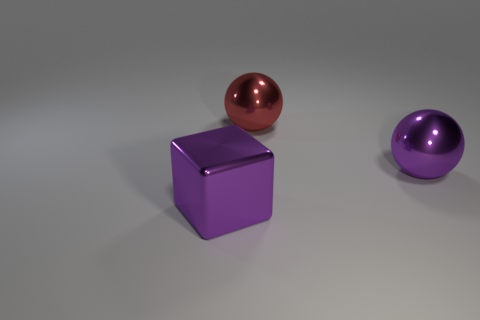The large thing that is the same color as the large cube is what shape?
Your response must be concise. Sphere. Are there any green cylinders?
Provide a succinct answer. No. What size is the red ball that is made of the same material as the purple sphere?
Offer a very short reply. Large. The purple metallic thing behind the object in front of the large ball that is on the right side of the large red metal sphere is what shape?
Offer a very short reply. Sphere. Are there the same number of purple blocks that are on the left side of the big shiny cube and small green things?
Offer a very short reply. Yes. There is a metal ball that is the same color as the cube; what size is it?
Provide a succinct answer. Large. How many things are big metal objects on the right side of the big red shiny thing or purple objects?
Your answer should be very brief. 2. Is the number of blocks that are behind the big red sphere the same as the number of large balls that are in front of the large metal cube?
Your response must be concise. Yes. How many other things are there of the same shape as the large red thing?
Your answer should be compact. 1. Does the thing left of the red object have the same size as the purple metallic object behind the purple cube?
Make the answer very short. Yes. 